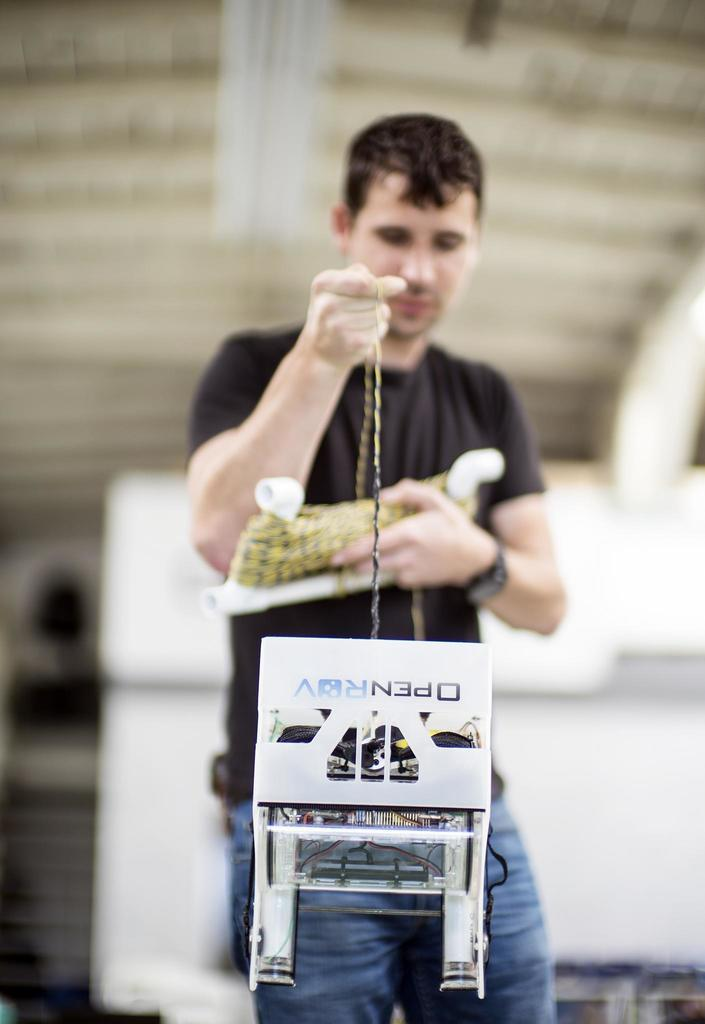Who is present in the image? There is a man in the image. What is the man wearing? The man is wearing a black T-shirt and blue jeans. What can be seen in the background of the image? There is a wall in the background of the image. What is the man holding in the image? The man is holding a rope. What type of copper is the man using to stimulate his brain in the image? There is no copper or indication of brain stimulation in the image; the man is simply holding a rope. 